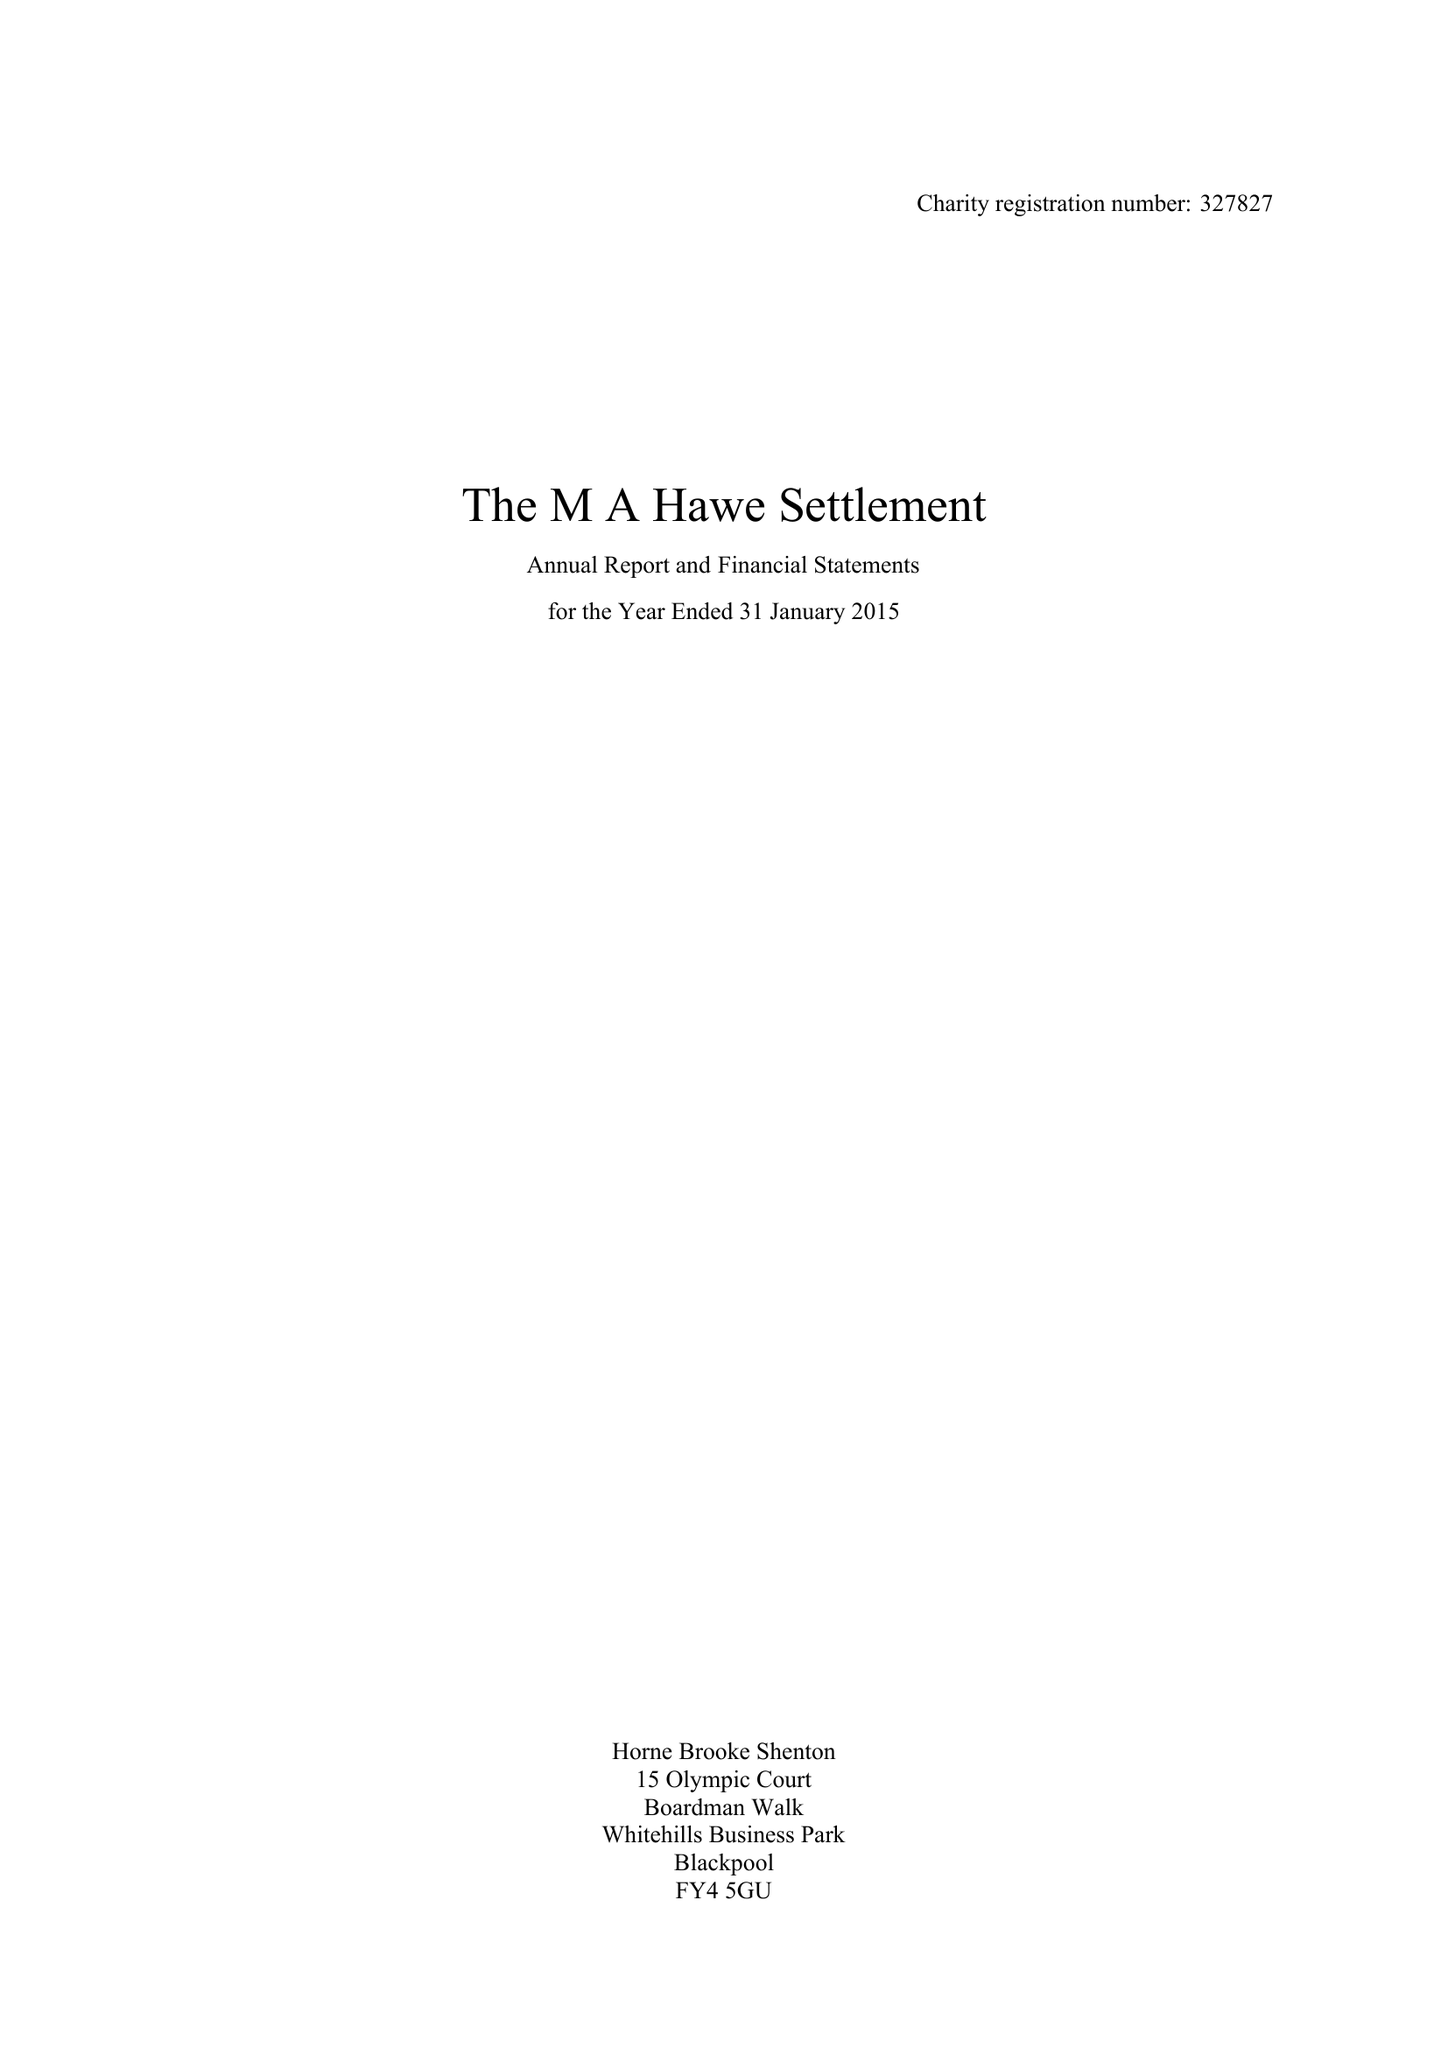What is the value for the income_annually_in_british_pounds?
Answer the question using a single word or phrase. 50021.00 